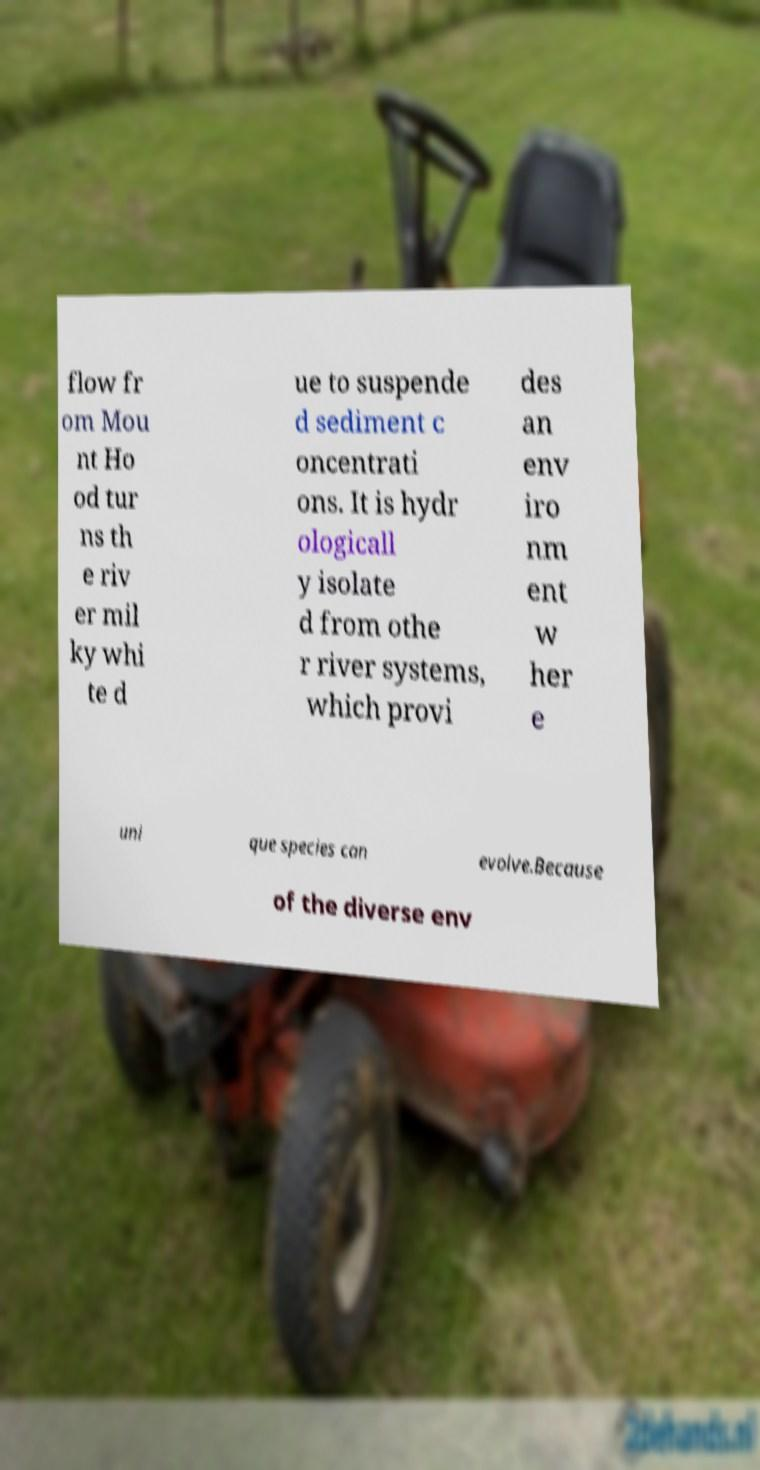What messages or text are displayed in this image? I need them in a readable, typed format. flow fr om Mou nt Ho od tur ns th e riv er mil ky whi te d ue to suspende d sediment c oncentrati ons. It is hydr ologicall y isolate d from othe r river systems, which provi des an env iro nm ent w her e uni que species can evolve.Because of the diverse env 